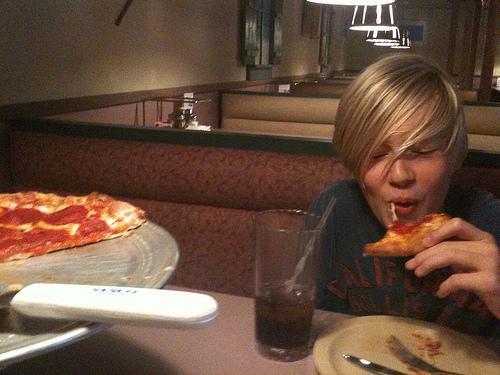How many people are there?
Give a very brief answer. 1. 